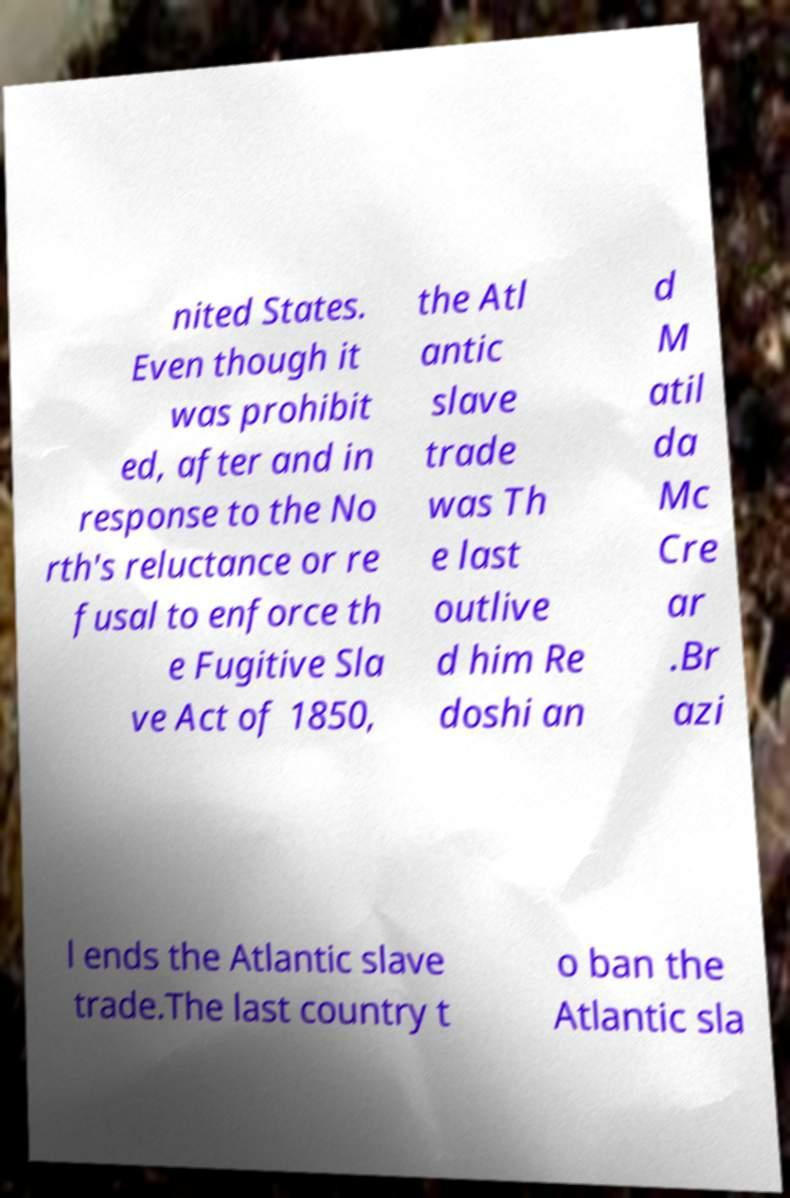Could you extract and type out the text from this image? nited States. Even though it was prohibit ed, after and in response to the No rth's reluctance or re fusal to enforce th e Fugitive Sla ve Act of 1850, the Atl antic slave trade was Th e last outlive d him Re doshi an d M atil da Mc Cre ar .Br azi l ends the Atlantic slave trade.The last country t o ban the Atlantic sla 